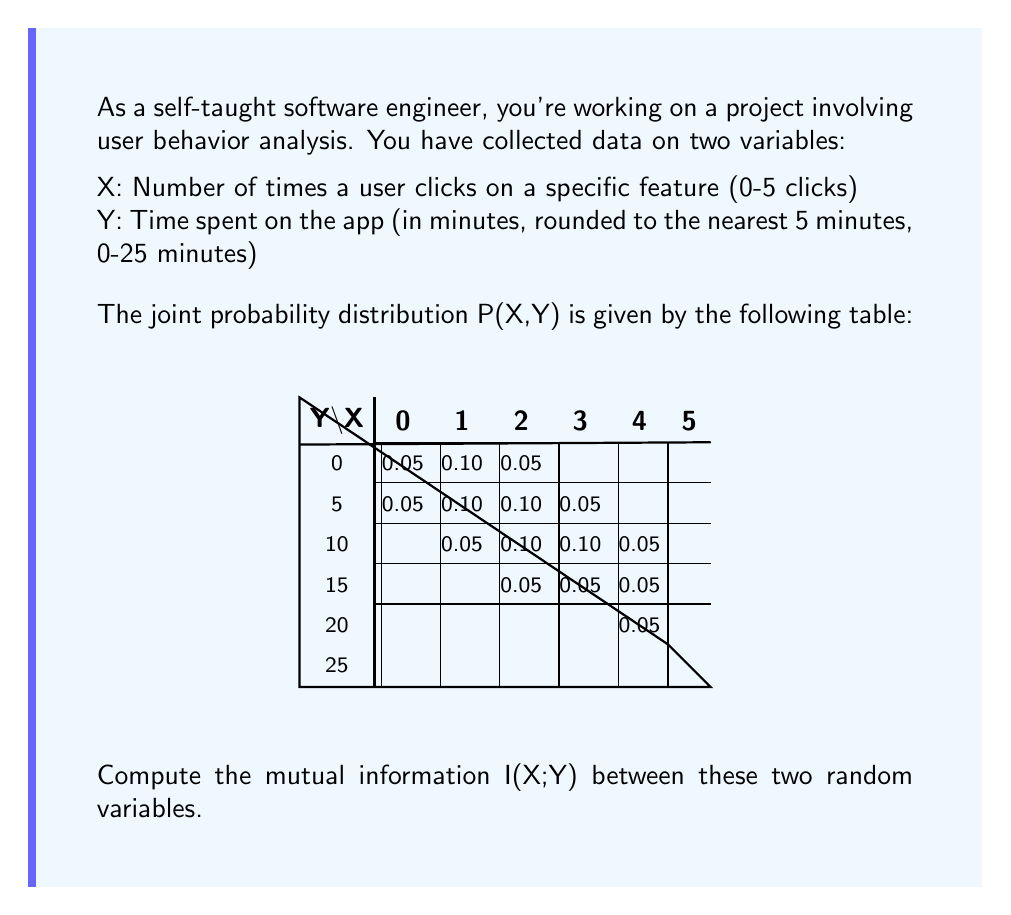Solve this math problem. To compute the mutual information I(X;Y), we'll follow these steps:

1) First, recall the formula for mutual information:
   $$I(X;Y) = \sum_{x,y} P(x,y) \log_2 \frac{P(x,y)}{P(x)P(y)}$$

2) We need to calculate P(x) and P(y) from the joint distribution:

   P(X=0) = 0.05
   P(X=1) = 0.15
   P(X=2) = 0.25
   P(X=3) = 0.30
   P(X=4) = 0.20
   P(X=5) = 0.05

   P(Y=0) = 0.20
   P(Y=5) = 0.30
   P(Y=10) = 0.30
   P(Y=15) = 0.15
   P(Y=20) = 0.05

3) Now, for each non-zero P(x,y), we calculate P(x,y) * log_2(P(x,y) / (P(x)P(y))):

   0.05 * log_2(0.05 / (0.05 * 0.20)) = 0.1610
   0.10 * log_2(0.10 / (0.15 * 0.20)) = 0.2075
   0.05 * log_2(0.05 / (0.25 * 0.20)) = 0.0000
   0.05 * log_2(0.05 / (0.05 * 0.30)) = 0.2075
   0.10 * log_2(0.10 / (0.15 * 0.30)) = 0.1610
   0.10 * log_2(0.10 / (0.25 * 0.30)) = 0.0000
   0.05 * log_2(0.05 / (0.30 * 0.30)) = -0.2630
   0.05 * log_2(0.05 / (0.15 * 0.30)) = 0.0000
   0.10 * log_2(0.10 / (0.25 * 0.30)) = 0.0000
   0.10 * log_2(0.10 / (0.30 * 0.30)) = 0.0000
   0.05 * log_2(0.05 / (0.20 * 0.30)) = -0.1610
   0.05 * log_2(0.05 / (0.25 * 0.15)) = 0.0875
   0.05 * log_2(0.05 / (0.30 * 0.15)) = 0.0000
   0.05 * log_2(0.05 / (0.20 * 0.15)) = 0.1610
   0.05 * log_2(0.05 / (0.20 * 0.05)) = 0.5850

4) Sum up all these values:

   I(X;Y) = 1.1465 bits

This value represents the amount of information shared between the number of clicks and the time spent on the app.
Answer: 1.1465 bits 